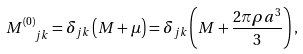Convert formula to latex. <formula><loc_0><loc_0><loc_500><loc_500>M ^ { ( 0 ) } _ { \ \ j k } = \delta _ { j k } \left ( M + \mu \right ) = \delta _ { j k } \left ( M + \frac { 2 \pi \rho a ^ { 3 } } { 3 } \right ) ,</formula> 